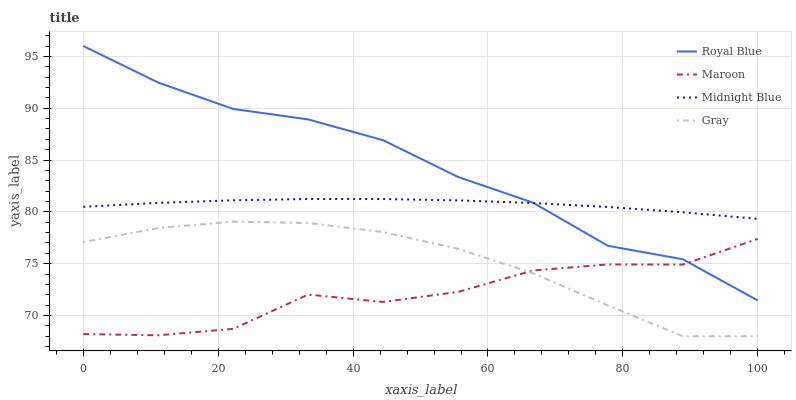Does Maroon have the minimum area under the curve?
Answer yes or no. Yes. Does Royal Blue have the maximum area under the curve?
Answer yes or no. Yes. Does Midnight Blue have the minimum area under the curve?
Answer yes or no. No. Does Midnight Blue have the maximum area under the curve?
Answer yes or no. No. Is Midnight Blue the smoothest?
Answer yes or no. Yes. Is Maroon the roughest?
Answer yes or no. Yes. Is Maroon the smoothest?
Answer yes or no. No. Is Midnight Blue the roughest?
Answer yes or no. No. Does Maroon have the lowest value?
Answer yes or no. No. Does Royal Blue have the highest value?
Answer yes or no. Yes. Does Midnight Blue have the highest value?
Answer yes or no. No. Is Gray less than Midnight Blue?
Answer yes or no. Yes. Is Midnight Blue greater than Maroon?
Answer yes or no. Yes. Does Gray intersect Maroon?
Answer yes or no. Yes. Is Gray less than Maroon?
Answer yes or no. No. Is Gray greater than Maroon?
Answer yes or no. No. Does Gray intersect Midnight Blue?
Answer yes or no. No. 